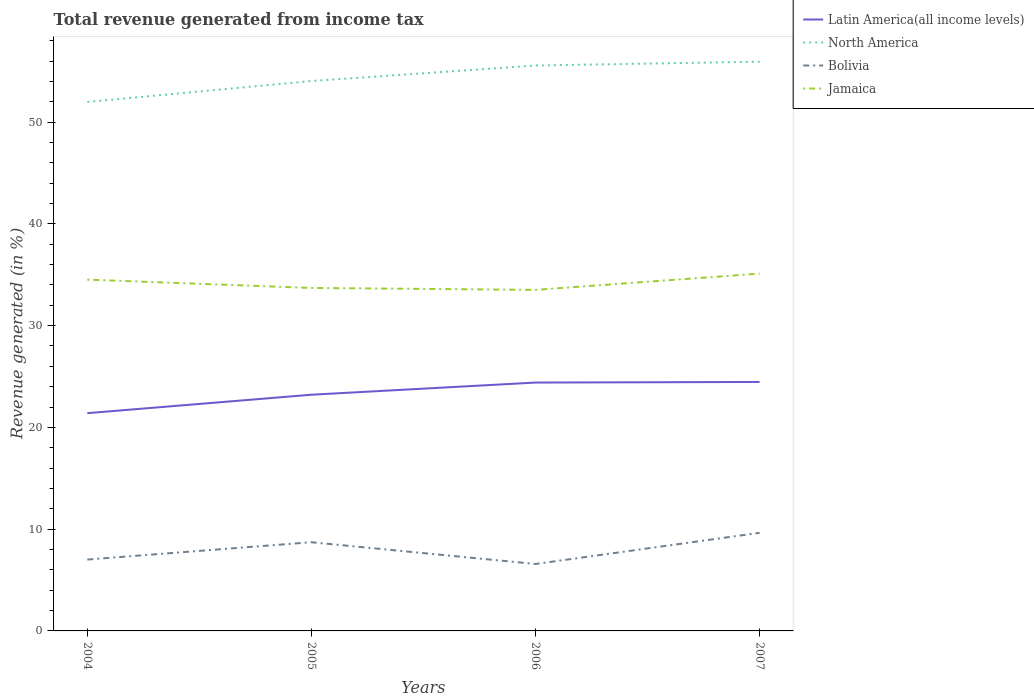Is the number of lines equal to the number of legend labels?
Provide a succinct answer. Yes. Across all years, what is the maximum total revenue generated in Jamaica?
Provide a short and direct response. 33.52. What is the total total revenue generated in Latin America(all income levels) in the graph?
Your answer should be very brief. -3.07. What is the difference between the highest and the second highest total revenue generated in Latin America(all income levels)?
Your response must be concise. 3.07. How many legend labels are there?
Offer a very short reply. 4. What is the title of the graph?
Keep it short and to the point. Total revenue generated from income tax. What is the label or title of the Y-axis?
Your answer should be very brief. Revenue generated (in %). What is the Revenue generated (in %) of Latin America(all income levels) in 2004?
Ensure brevity in your answer.  21.4. What is the Revenue generated (in %) in North America in 2004?
Your response must be concise. 51.98. What is the Revenue generated (in %) in Bolivia in 2004?
Give a very brief answer. 7.01. What is the Revenue generated (in %) of Jamaica in 2004?
Your response must be concise. 34.52. What is the Revenue generated (in %) of Latin America(all income levels) in 2005?
Offer a terse response. 23.21. What is the Revenue generated (in %) in North America in 2005?
Your answer should be compact. 54.04. What is the Revenue generated (in %) in Bolivia in 2005?
Provide a succinct answer. 8.72. What is the Revenue generated (in %) in Jamaica in 2005?
Your response must be concise. 33.7. What is the Revenue generated (in %) of Latin America(all income levels) in 2006?
Your answer should be compact. 24.41. What is the Revenue generated (in %) in North America in 2006?
Provide a succinct answer. 55.56. What is the Revenue generated (in %) of Bolivia in 2006?
Make the answer very short. 6.58. What is the Revenue generated (in %) of Jamaica in 2006?
Ensure brevity in your answer.  33.52. What is the Revenue generated (in %) in Latin America(all income levels) in 2007?
Give a very brief answer. 24.47. What is the Revenue generated (in %) of North America in 2007?
Provide a succinct answer. 55.94. What is the Revenue generated (in %) of Bolivia in 2007?
Give a very brief answer. 9.64. What is the Revenue generated (in %) in Jamaica in 2007?
Make the answer very short. 35.11. Across all years, what is the maximum Revenue generated (in %) in Latin America(all income levels)?
Give a very brief answer. 24.47. Across all years, what is the maximum Revenue generated (in %) of North America?
Keep it short and to the point. 55.94. Across all years, what is the maximum Revenue generated (in %) of Bolivia?
Your response must be concise. 9.64. Across all years, what is the maximum Revenue generated (in %) in Jamaica?
Provide a succinct answer. 35.11. Across all years, what is the minimum Revenue generated (in %) of Latin America(all income levels)?
Give a very brief answer. 21.4. Across all years, what is the minimum Revenue generated (in %) of North America?
Give a very brief answer. 51.98. Across all years, what is the minimum Revenue generated (in %) of Bolivia?
Give a very brief answer. 6.58. Across all years, what is the minimum Revenue generated (in %) in Jamaica?
Keep it short and to the point. 33.52. What is the total Revenue generated (in %) in Latin America(all income levels) in the graph?
Your answer should be very brief. 93.48. What is the total Revenue generated (in %) in North America in the graph?
Your response must be concise. 217.52. What is the total Revenue generated (in %) of Bolivia in the graph?
Offer a very short reply. 31.95. What is the total Revenue generated (in %) of Jamaica in the graph?
Your answer should be compact. 136.85. What is the difference between the Revenue generated (in %) in Latin America(all income levels) in 2004 and that in 2005?
Your answer should be very brief. -1.81. What is the difference between the Revenue generated (in %) of North America in 2004 and that in 2005?
Ensure brevity in your answer.  -2.06. What is the difference between the Revenue generated (in %) in Bolivia in 2004 and that in 2005?
Provide a succinct answer. -1.7. What is the difference between the Revenue generated (in %) of Jamaica in 2004 and that in 2005?
Ensure brevity in your answer.  0.82. What is the difference between the Revenue generated (in %) of Latin America(all income levels) in 2004 and that in 2006?
Keep it short and to the point. -3.01. What is the difference between the Revenue generated (in %) in North America in 2004 and that in 2006?
Your answer should be very brief. -3.58. What is the difference between the Revenue generated (in %) in Bolivia in 2004 and that in 2006?
Give a very brief answer. 0.44. What is the difference between the Revenue generated (in %) of Jamaica in 2004 and that in 2006?
Provide a short and direct response. 1. What is the difference between the Revenue generated (in %) of Latin America(all income levels) in 2004 and that in 2007?
Offer a very short reply. -3.07. What is the difference between the Revenue generated (in %) of North America in 2004 and that in 2007?
Your answer should be very brief. -3.96. What is the difference between the Revenue generated (in %) of Bolivia in 2004 and that in 2007?
Your answer should be very brief. -2.63. What is the difference between the Revenue generated (in %) of Jamaica in 2004 and that in 2007?
Your response must be concise. -0.59. What is the difference between the Revenue generated (in %) of Latin America(all income levels) in 2005 and that in 2006?
Provide a short and direct response. -1.19. What is the difference between the Revenue generated (in %) of North America in 2005 and that in 2006?
Your answer should be very brief. -1.52. What is the difference between the Revenue generated (in %) of Bolivia in 2005 and that in 2006?
Provide a succinct answer. 2.14. What is the difference between the Revenue generated (in %) in Jamaica in 2005 and that in 2006?
Give a very brief answer. 0.19. What is the difference between the Revenue generated (in %) in Latin America(all income levels) in 2005 and that in 2007?
Offer a terse response. -1.25. What is the difference between the Revenue generated (in %) of Bolivia in 2005 and that in 2007?
Your answer should be compact. -0.93. What is the difference between the Revenue generated (in %) in Jamaica in 2005 and that in 2007?
Offer a terse response. -1.41. What is the difference between the Revenue generated (in %) of Latin America(all income levels) in 2006 and that in 2007?
Provide a short and direct response. -0.06. What is the difference between the Revenue generated (in %) in North America in 2006 and that in 2007?
Keep it short and to the point. -0.38. What is the difference between the Revenue generated (in %) of Bolivia in 2006 and that in 2007?
Provide a succinct answer. -3.06. What is the difference between the Revenue generated (in %) of Jamaica in 2006 and that in 2007?
Provide a succinct answer. -1.6. What is the difference between the Revenue generated (in %) in Latin America(all income levels) in 2004 and the Revenue generated (in %) in North America in 2005?
Your response must be concise. -32.64. What is the difference between the Revenue generated (in %) in Latin America(all income levels) in 2004 and the Revenue generated (in %) in Bolivia in 2005?
Provide a short and direct response. 12.68. What is the difference between the Revenue generated (in %) in Latin America(all income levels) in 2004 and the Revenue generated (in %) in Jamaica in 2005?
Your answer should be compact. -12.3. What is the difference between the Revenue generated (in %) in North America in 2004 and the Revenue generated (in %) in Bolivia in 2005?
Keep it short and to the point. 43.26. What is the difference between the Revenue generated (in %) in North America in 2004 and the Revenue generated (in %) in Jamaica in 2005?
Provide a short and direct response. 18.28. What is the difference between the Revenue generated (in %) in Bolivia in 2004 and the Revenue generated (in %) in Jamaica in 2005?
Offer a terse response. -26.69. What is the difference between the Revenue generated (in %) of Latin America(all income levels) in 2004 and the Revenue generated (in %) of North America in 2006?
Offer a terse response. -34.16. What is the difference between the Revenue generated (in %) in Latin America(all income levels) in 2004 and the Revenue generated (in %) in Bolivia in 2006?
Ensure brevity in your answer.  14.82. What is the difference between the Revenue generated (in %) in Latin America(all income levels) in 2004 and the Revenue generated (in %) in Jamaica in 2006?
Provide a succinct answer. -12.12. What is the difference between the Revenue generated (in %) of North America in 2004 and the Revenue generated (in %) of Bolivia in 2006?
Keep it short and to the point. 45.4. What is the difference between the Revenue generated (in %) in North America in 2004 and the Revenue generated (in %) in Jamaica in 2006?
Offer a terse response. 18.46. What is the difference between the Revenue generated (in %) of Bolivia in 2004 and the Revenue generated (in %) of Jamaica in 2006?
Your answer should be compact. -26.5. What is the difference between the Revenue generated (in %) in Latin America(all income levels) in 2004 and the Revenue generated (in %) in North America in 2007?
Your response must be concise. -34.54. What is the difference between the Revenue generated (in %) of Latin America(all income levels) in 2004 and the Revenue generated (in %) of Bolivia in 2007?
Make the answer very short. 11.76. What is the difference between the Revenue generated (in %) of Latin America(all income levels) in 2004 and the Revenue generated (in %) of Jamaica in 2007?
Ensure brevity in your answer.  -13.71. What is the difference between the Revenue generated (in %) in North America in 2004 and the Revenue generated (in %) in Bolivia in 2007?
Your answer should be compact. 42.34. What is the difference between the Revenue generated (in %) in North America in 2004 and the Revenue generated (in %) in Jamaica in 2007?
Provide a short and direct response. 16.87. What is the difference between the Revenue generated (in %) of Bolivia in 2004 and the Revenue generated (in %) of Jamaica in 2007?
Offer a very short reply. -28.1. What is the difference between the Revenue generated (in %) in Latin America(all income levels) in 2005 and the Revenue generated (in %) in North America in 2006?
Make the answer very short. -32.35. What is the difference between the Revenue generated (in %) in Latin America(all income levels) in 2005 and the Revenue generated (in %) in Bolivia in 2006?
Provide a succinct answer. 16.63. What is the difference between the Revenue generated (in %) in Latin America(all income levels) in 2005 and the Revenue generated (in %) in Jamaica in 2006?
Offer a very short reply. -10.3. What is the difference between the Revenue generated (in %) in North America in 2005 and the Revenue generated (in %) in Bolivia in 2006?
Ensure brevity in your answer.  47.46. What is the difference between the Revenue generated (in %) of North America in 2005 and the Revenue generated (in %) of Jamaica in 2006?
Provide a succinct answer. 20.52. What is the difference between the Revenue generated (in %) of Bolivia in 2005 and the Revenue generated (in %) of Jamaica in 2006?
Your response must be concise. -24.8. What is the difference between the Revenue generated (in %) in Latin America(all income levels) in 2005 and the Revenue generated (in %) in North America in 2007?
Your response must be concise. -32.73. What is the difference between the Revenue generated (in %) in Latin America(all income levels) in 2005 and the Revenue generated (in %) in Bolivia in 2007?
Ensure brevity in your answer.  13.57. What is the difference between the Revenue generated (in %) of Latin America(all income levels) in 2005 and the Revenue generated (in %) of Jamaica in 2007?
Provide a short and direct response. -11.9. What is the difference between the Revenue generated (in %) in North America in 2005 and the Revenue generated (in %) in Bolivia in 2007?
Provide a short and direct response. 44.4. What is the difference between the Revenue generated (in %) of North America in 2005 and the Revenue generated (in %) of Jamaica in 2007?
Make the answer very short. 18.93. What is the difference between the Revenue generated (in %) of Bolivia in 2005 and the Revenue generated (in %) of Jamaica in 2007?
Your response must be concise. -26.4. What is the difference between the Revenue generated (in %) of Latin America(all income levels) in 2006 and the Revenue generated (in %) of North America in 2007?
Your answer should be very brief. -31.53. What is the difference between the Revenue generated (in %) of Latin America(all income levels) in 2006 and the Revenue generated (in %) of Bolivia in 2007?
Your answer should be very brief. 14.77. What is the difference between the Revenue generated (in %) of Latin America(all income levels) in 2006 and the Revenue generated (in %) of Jamaica in 2007?
Your answer should be compact. -10.71. What is the difference between the Revenue generated (in %) of North America in 2006 and the Revenue generated (in %) of Bolivia in 2007?
Give a very brief answer. 45.92. What is the difference between the Revenue generated (in %) in North America in 2006 and the Revenue generated (in %) in Jamaica in 2007?
Offer a terse response. 20.45. What is the difference between the Revenue generated (in %) in Bolivia in 2006 and the Revenue generated (in %) in Jamaica in 2007?
Provide a short and direct response. -28.53. What is the average Revenue generated (in %) of Latin America(all income levels) per year?
Your answer should be very brief. 23.37. What is the average Revenue generated (in %) in North America per year?
Make the answer very short. 54.38. What is the average Revenue generated (in %) in Bolivia per year?
Your answer should be very brief. 7.99. What is the average Revenue generated (in %) of Jamaica per year?
Provide a short and direct response. 34.21. In the year 2004, what is the difference between the Revenue generated (in %) of Latin America(all income levels) and Revenue generated (in %) of North America?
Offer a terse response. -30.58. In the year 2004, what is the difference between the Revenue generated (in %) in Latin America(all income levels) and Revenue generated (in %) in Bolivia?
Offer a very short reply. 14.38. In the year 2004, what is the difference between the Revenue generated (in %) of Latin America(all income levels) and Revenue generated (in %) of Jamaica?
Give a very brief answer. -13.12. In the year 2004, what is the difference between the Revenue generated (in %) in North America and Revenue generated (in %) in Bolivia?
Provide a succinct answer. 44.97. In the year 2004, what is the difference between the Revenue generated (in %) of North America and Revenue generated (in %) of Jamaica?
Your response must be concise. 17.46. In the year 2004, what is the difference between the Revenue generated (in %) in Bolivia and Revenue generated (in %) in Jamaica?
Offer a terse response. -27.51. In the year 2005, what is the difference between the Revenue generated (in %) of Latin America(all income levels) and Revenue generated (in %) of North America?
Keep it short and to the point. -30.83. In the year 2005, what is the difference between the Revenue generated (in %) of Latin America(all income levels) and Revenue generated (in %) of Bolivia?
Offer a very short reply. 14.5. In the year 2005, what is the difference between the Revenue generated (in %) of Latin America(all income levels) and Revenue generated (in %) of Jamaica?
Offer a very short reply. -10.49. In the year 2005, what is the difference between the Revenue generated (in %) in North America and Revenue generated (in %) in Bolivia?
Your response must be concise. 45.32. In the year 2005, what is the difference between the Revenue generated (in %) of North America and Revenue generated (in %) of Jamaica?
Provide a succinct answer. 20.33. In the year 2005, what is the difference between the Revenue generated (in %) in Bolivia and Revenue generated (in %) in Jamaica?
Ensure brevity in your answer.  -24.99. In the year 2006, what is the difference between the Revenue generated (in %) in Latin America(all income levels) and Revenue generated (in %) in North America?
Provide a short and direct response. -31.16. In the year 2006, what is the difference between the Revenue generated (in %) of Latin America(all income levels) and Revenue generated (in %) of Bolivia?
Your answer should be very brief. 17.83. In the year 2006, what is the difference between the Revenue generated (in %) in Latin America(all income levels) and Revenue generated (in %) in Jamaica?
Provide a short and direct response. -9.11. In the year 2006, what is the difference between the Revenue generated (in %) of North America and Revenue generated (in %) of Bolivia?
Keep it short and to the point. 48.98. In the year 2006, what is the difference between the Revenue generated (in %) of North America and Revenue generated (in %) of Jamaica?
Give a very brief answer. 22.05. In the year 2006, what is the difference between the Revenue generated (in %) of Bolivia and Revenue generated (in %) of Jamaica?
Offer a very short reply. -26.94. In the year 2007, what is the difference between the Revenue generated (in %) of Latin America(all income levels) and Revenue generated (in %) of North America?
Keep it short and to the point. -31.47. In the year 2007, what is the difference between the Revenue generated (in %) of Latin America(all income levels) and Revenue generated (in %) of Bolivia?
Provide a short and direct response. 14.82. In the year 2007, what is the difference between the Revenue generated (in %) of Latin America(all income levels) and Revenue generated (in %) of Jamaica?
Your answer should be compact. -10.65. In the year 2007, what is the difference between the Revenue generated (in %) of North America and Revenue generated (in %) of Bolivia?
Make the answer very short. 46.3. In the year 2007, what is the difference between the Revenue generated (in %) of North America and Revenue generated (in %) of Jamaica?
Offer a terse response. 20.83. In the year 2007, what is the difference between the Revenue generated (in %) of Bolivia and Revenue generated (in %) of Jamaica?
Ensure brevity in your answer.  -25.47. What is the ratio of the Revenue generated (in %) of Latin America(all income levels) in 2004 to that in 2005?
Provide a short and direct response. 0.92. What is the ratio of the Revenue generated (in %) of North America in 2004 to that in 2005?
Provide a short and direct response. 0.96. What is the ratio of the Revenue generated (in %) of Bolivia in 2004 to that in 2005?
Make the answer very short. 0.8. What is the ratio of the Revenue generated (in %) in Jamaica in 2004 to that in 2005?
Offer a terse response. 1.02. What is the ratio of the Revenue generated (in %) in Latin America(all income levels) in 2004 to that in 2006?
Keep it short and to the point. 0.88. What is the ratio of the Revenue generated (in %) of North America in 2004 to that in 2006?
Your answer should be compact. 0.94. What is the ratio of the Revenue generated (in %) in Bolivia in 2004 to that in 2006?
Keep it short and to the point. 1.07. What is the ratio of the Revenue generated (in %) of Jamaica in 2004 to that in 2006?
Your answer should be very brief. 1.03. What is the ratio of the Revenue generated (in %) in Latin America(all income levels) in 2004 to that in 2007?
Your answer should be compact. 0.87. What is the ratio of the Revenue generated (in %) in North America in 2004 to that in 2007?
Keep it short and to the point. 0.93. What is the ratio of the Revenue generated (in %) of Bolivia in 2004 to that in 2007?
Offer a very short reply. 0.73. What is the ratio of the Revenue generated (in %) in Jamaica in 2004 to that in 2007?
Ensure brevity in your answer.  0.98. What is the ratio of the Revenue generated (in %) in Latin America(all income levels) in 2005 to that in 2006?
Keep it short and to the point. 0.95. What is the ratio of the Revenue generated (in %) of North America in 2005 to that in 2006?
Provide a succinct answer. 0.97. What is the ratio of the Revenue generated (in %) in Bolivia in 2005 to that in 2006?
Provide a short and direct response. 1.32. What is the ratio of the Revenue generated (in %) in Jamaica in 2005 to that in 2006?
Your answer should be compact. 1.01. What is the ratio of the Revenue generated (in %) in Latin America(all income levels) in 2005 to that in 2007?
Your answer should be very brief. 0.95. What is the ratio of the Revenue generated (in %) of Bolivia in 2005 to that in 2007?
Make the answer very short. 0.9. What is the ratio of the Revenue generated (in %) of Jamaica in 2005 to that in 2007?
Your answer should be compact. 0.96. What is the ratio of the Revenue generated (in %) of Bolivia in 2006 to that in 2007?
Make the answer very short. 0.68. What is the ratio of the Revenue generated (in %) of Jamaica in 2006 to that in 2007?
Provide a succinct answer. 0.95. What is the difference between the highest and the second highest Revenue generated (in %) in Latin America(all income levels)?
Provide a short and direct response. 0.06. What is the difference between the highest and the second highest Revenue generated (in %) of North America?
Keep it short and to the point. 0.38. What is the difference between the highest and the second highest Revenue generated (in %) of Bolivia?
Keep it short and to the point. 0.93. What is the difference between the highest and the second highest Revenue generated (in %) in Jamaica?
Keep it short and to the point. 0.59. What is the difference between the highest and the lowest Revenue generated (in %) of Latin America(all income levels)?
Provide a succinct answer. 3.07. What is the difference between the highest and the lowest Revenue generated (in %) of North America?
Provide a succinct answer. 3.96. What is the difference between the highest and the lowest Revenue generated (in %) of Bolivia?
Ensure brevity in your answer.  3.06. What is the difference between the highest and the lowest Revenue generated (in %) in Jamaica?
Your answer should be very brief. 1.6. 